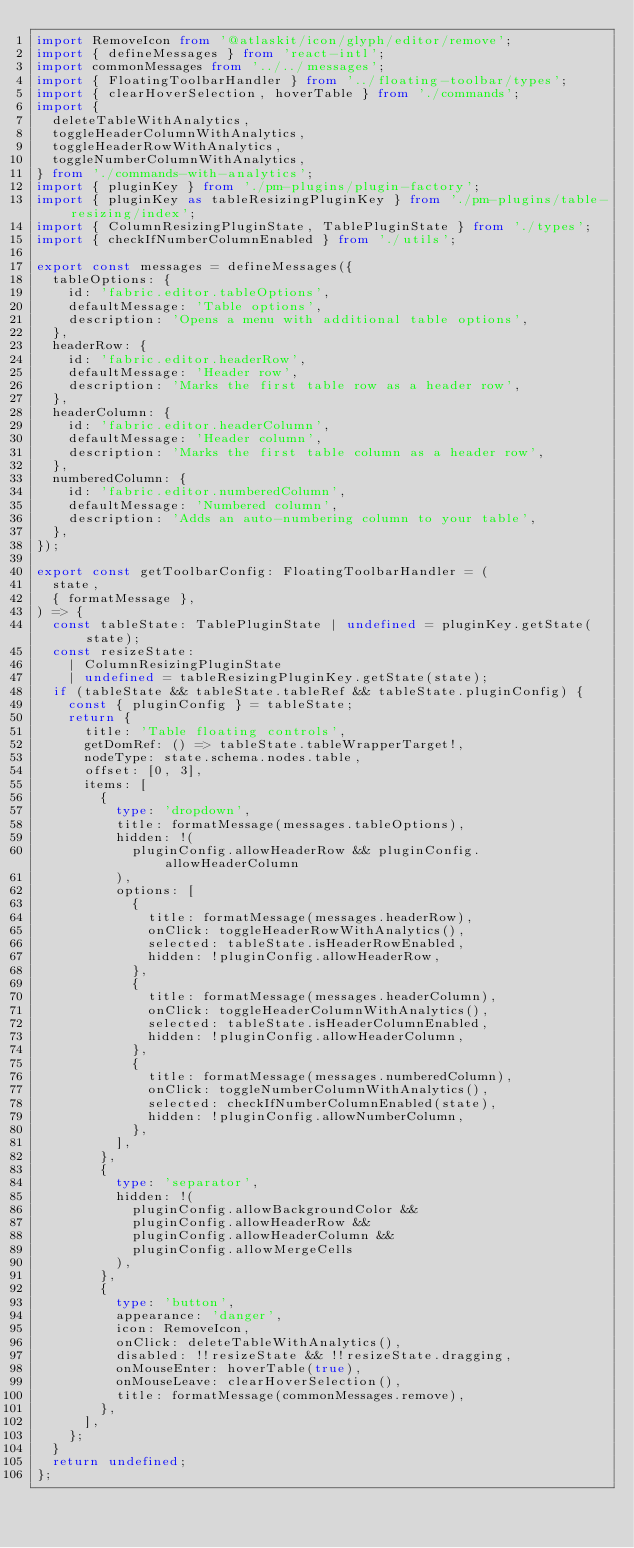<code> <loc_0><loc_0><loc_500><loc_500><_TypeScript_>import RemoveIcon from '@atlaskit/icon/glyph/editor/remove';
import { defineMessages } from 'react-intl';
import commonMessages from '../../messages';
import { FloatingToolbarHandler } from '../floating-toolbar/types';
import { clearHoverSelection, hoverTable } from './commands';
import {
  deleteTableWithAnalytics,
  toggleHeaderColumnWithAnalytics,
  toggleHeaderRowWithAnalytics,
  toggleNumberColumnWithAnalytics,
} from './commands-with-analytics';
import { pluginKey } from './pm-plugins/plugin-factory';
import { pluginKey as tableResizingPluginKey } from './pm-plugins/table-resizing/index';
import { ColumnResizingPluginState, TablePluginState } from './types';
import { checkIfNumberColumnEnabled } from './utils';

export const messages = defineMessages({
  tableOptions: {
    id: 'fabric.editor.tableOptions',
    defaultMessage: 'Table options',
    description: 'Opens a menu with additional table options',
  },
  headerRow: {
    id: 'fabric.editor.headerRow',
    defaultMessage: 'Header row',
    description: 'Marks the first table row as a header row',
  },
  headerColumn: {
    id: 'fabric.editor.headerColumn',
    defaultMessage: 'Header column',
    description: 'Marks the first table column as a header row',
  },
  numberedColumn: {
    id: 'fabric.editor.numberedColumn',
    defaultMessage: 'Numbered column',
    description: 'Adds an auto-numbering column to your table',
  },
});

export const getToolbarConfig: FloatingToolbarHandler = (
  state,
  { formatMessage },
) => {
  const tableState: TablePluginState | undefined = pluginKey.getState(state);
  const resizeState:
    | ColumnResizingPluginState
    | undefined = tableResizingPluginKey.getState(state);
  if (tableState && tableState.tableRef && tableState.pluginConfig) {
    const { pluginConfig } = tableState;
    return {
      title: 'Table floating controls',
      getDomRef: () => tableState.tableWrapperTarget!,
      nodeType: state.schema.nodes.table,
      offset: [0, 3],
      items: [
        {
          type: 'dropdown',
          title: formatMessage(messages.tableOptions),
          hidden: !(
            pluginConfig.allowHeaderRow && pluginConfig.allowHeaderColumn
          ),
          options: [
            {
              title: formatMessage(messages.headerRow),
              onClick: toggleHeaderRowWithAnalytics(),
              selected: tableState.isHeaderRowEnabled,
              hidden: !pluginConfig.allowHeaderRow,
            },
            {
              title: formatMessage(messages.headerColumn),
              onClick: toggleHeaderColumnWithAnalytics(),
              selected: tableState.isHeaderColumnEnabled,
              hidden: !pluginConfig.allowHeaderColumn,
            },
            {
              title: formatMessage(messages.numberedColumn),
              onClick: toggleNumberColumnWithAnalytics(),
              selected: checkIfNumberColumnEnabled(state),
              hidden: !pluginConfig.allowNumberColumn,
            },
          ],
        },
        {
          type: 'separator',
          hidden: !(
            pluginConfig.allowBackgroundColor &&
            pluginConfig.allowHeaderRow &&
            pluginConfig.allowHeaderColumn &&
            pluginConfig.allowMergeCells
          ),
        },
        {
          type: 'button',
          appearance: 'danger',
          icon: RemoveIcon,
          onClick: deleteTableWithAnalytics(),
          disabled: !!resizeState && !!resizeState.dragging,
          onMouseEnter: hoverTable(true),
          onMouseLeave: clearHoverSelection(),
          title: formatMessage(commonMessages.remove),
        },
      ],
    };
  }
  return undefined;
};
</code> 